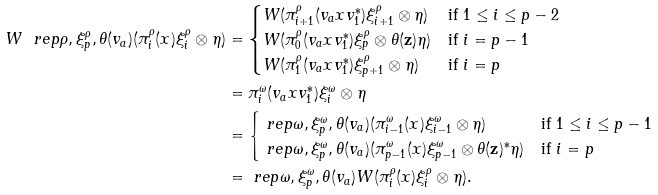Convert formula to latex. <formula><loc_0><loc_0><loc_500><loc_500>W \ r e p { \rho , \xi ^ { \rho } _ { p } , \theta } ( v _ { a } ) ( \pi ^ { \rho } _ { i } ( x ) \xi ^ { \rho } _ { i } \otimes \eta ) & = \begin{cases} W ( \pi ^ { \rho } _ { i + 1 } ( v _ { a } x v _ { 1 } ^ { * } ) \xi ^ { \rho } _ { i + 1 } \otimes \eta ) & \text {if $1 \leq i \leq p-2$} \\ W ( \pi ^ { \rho } _ { 0 } ( v _ { a } x v _ { 1 } ^ { * } ) \xi ^ { \rho } _ { p } \otimes \theta ( \mathbf z ) \eta ) & \text {if $i = p-1$} \\ W ( \pi ^ { \rho } _ { 1 } ( v _ { a } x v _ { 1 } ^ { * } ) \xi ^ { \rho } _ { p + 1 } \otimes \eta ) & \text {if $i = p$} \end{cases} \\ & = \pi ^ { \omega } _ { i } ( v _ { a } x v _ { 1 } ^ { * } ) \xi ^ { \omega } _ { i } \otimes \eta \\ & = \begin{cases} \ r e p { \omega , \xi ^ { \omega } _ { p } , \theta } ( v _ { a } ) ( \pi ^ { \omega } _ { i - 1 } ( x ) \xi ^ { \omega } _ { i - 1 } \otimes \eta ) & \text {if $1 \leq i \leq p-1$} \\ \ r e p { \omega , \xi ^ { \omega } _ { p } , \theta } ( v _ { a } ) ( \pi ^ { \omega } _ { p - 1 } ( x ) \xi ^ { \omega } _ { p - 1 } \otimes \theta ( \mathbf z ) ^ { * } \eta ) & \text {if $i = p$} \end{cases} \\ & = \ r e p { \omega , \xi ^ { \omega } _ { p } , \theta } ( v _ { a } ) W ( \pi ^ { \rho } _ { i } ( x ) \xi ^ { \rho } _ { i } \otimes \eta ) .</formula> 